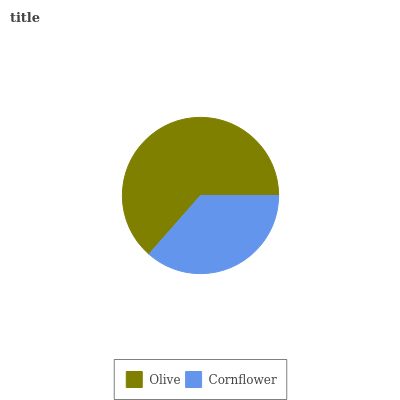Is Cornflower the minimum?
Answer yes or no. Yes. Is Olive the maximum?
Answer yes or no. Yes. Is Cornflower the maximum?
Answer yes or no. No. Is Olive greater than Cornflower?
Answer yes or no. Yes. Is Cornflower less than Olive?
Answer yes or no. Yes. Is Cornflower greater than Olive?
Answer yes or no. No. Is Olive less than Cornflower?
Answer yes or no. No. Is Olive the high median?
Answer yes or no. Yes. Is Cornflower the low median?
Answer yes or no. Yes. Is Cornflower the high median?
Answer yes or no. No. Is Olive the low median?
Answer yes or no. No. 